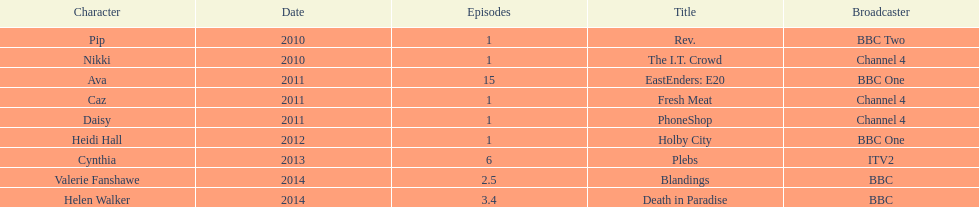What was the previous role this actress played before playing cynthia in plebs? Heidi Hall. 